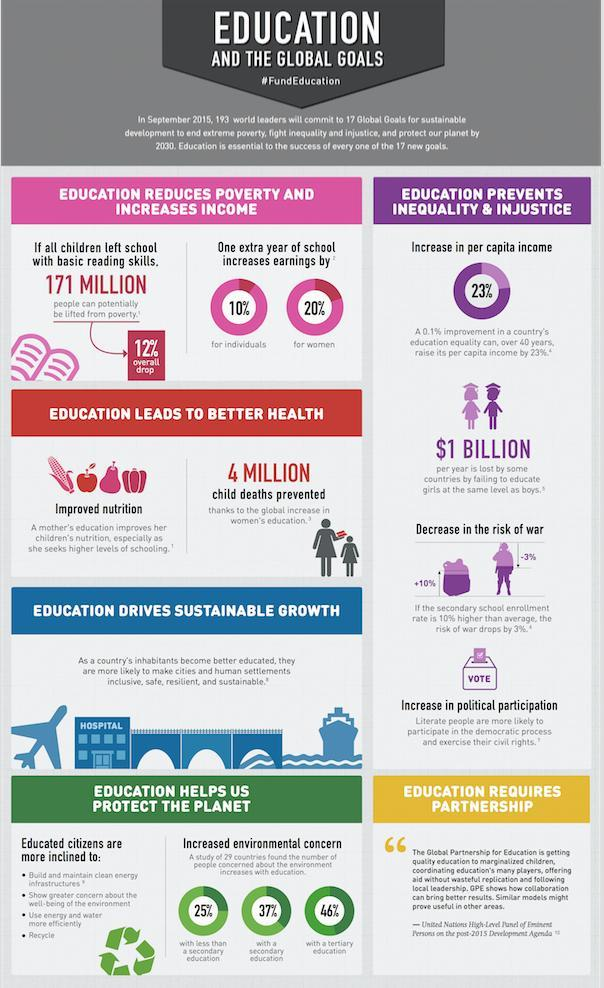How many of the people with tertiary education showed increased environmental concern?
Answer the question with a short phrase. 46% What is the loss per year for countries that fail to educate girls as much as boys? $1 Billion What is % increase in earnings for women with one extra year of education? 20% What would be the % drop in poverty if all children developed basic reading skills? 12% Who are more likely to recycle and make efficient use of water? Educated citizens Increase in what helped to prevent 4 million child deaths? women's education 